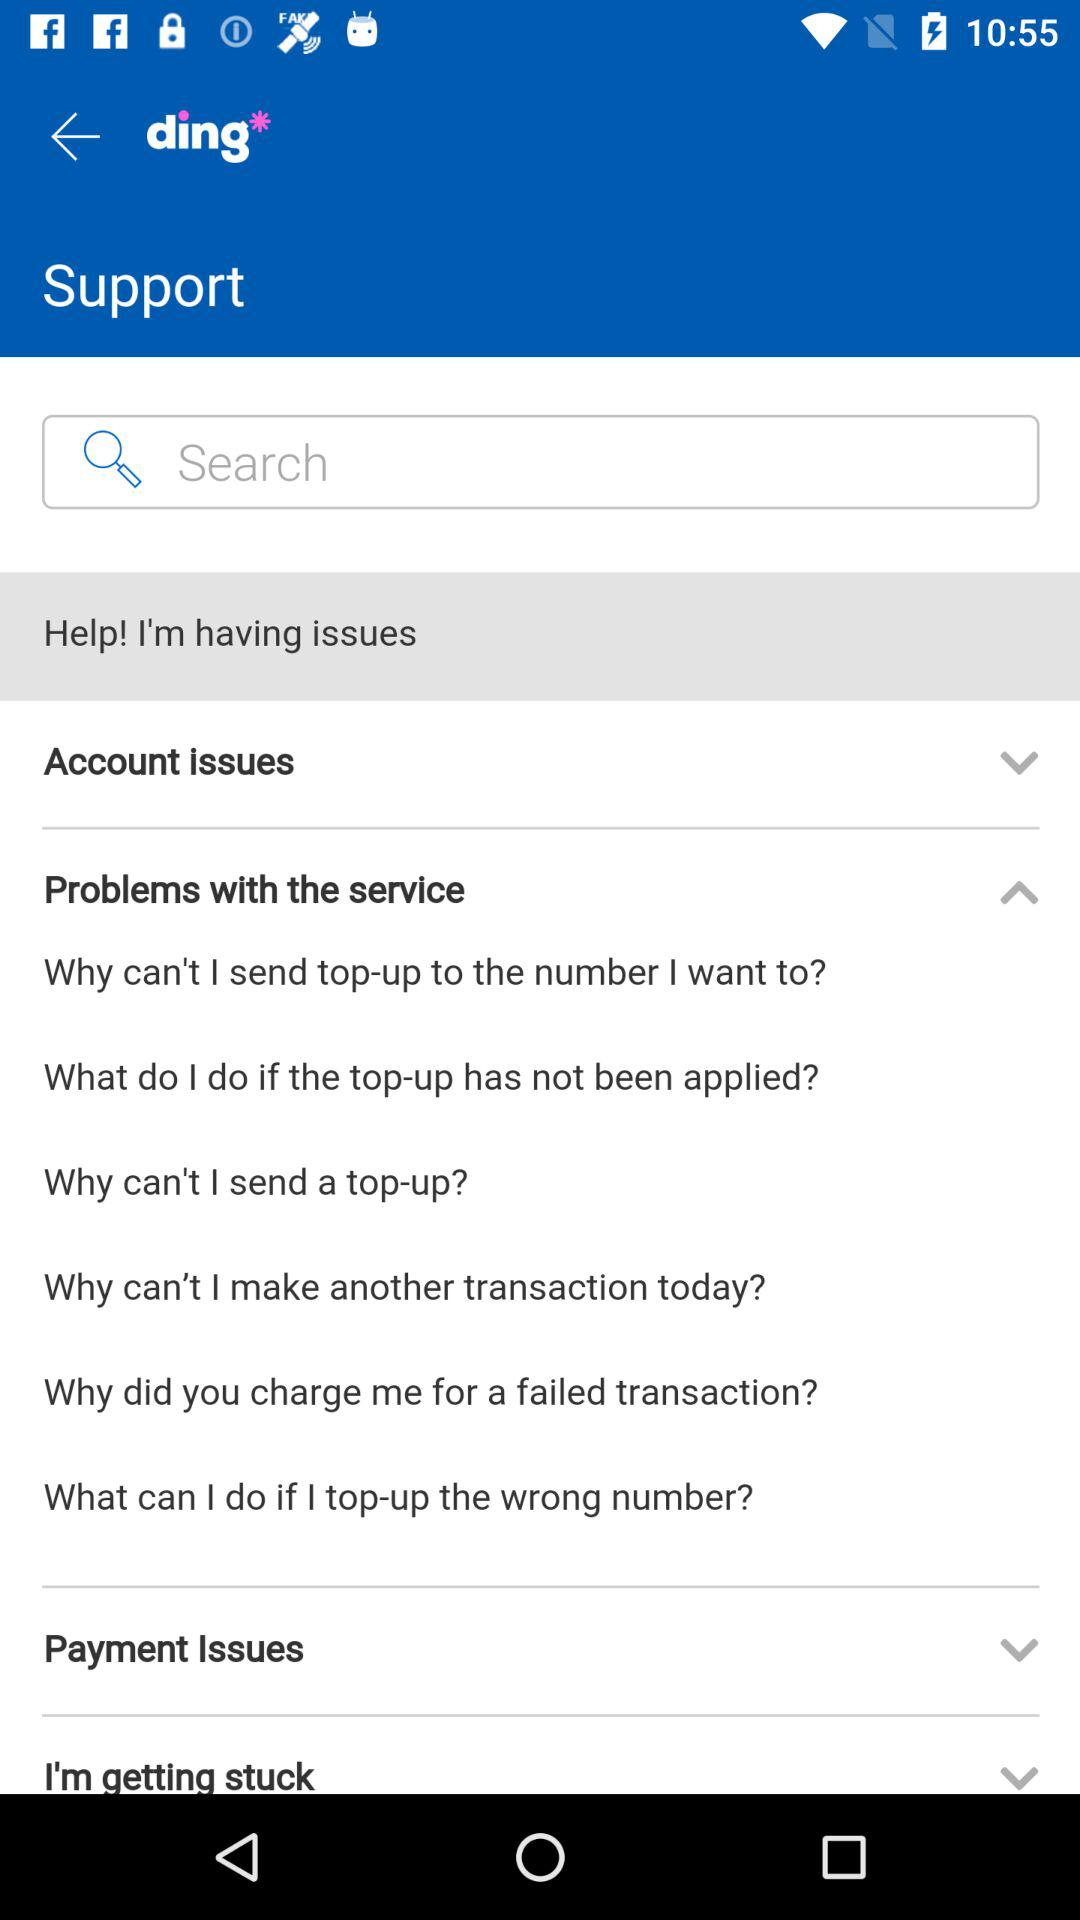What is the application name? The application name is "ding". 